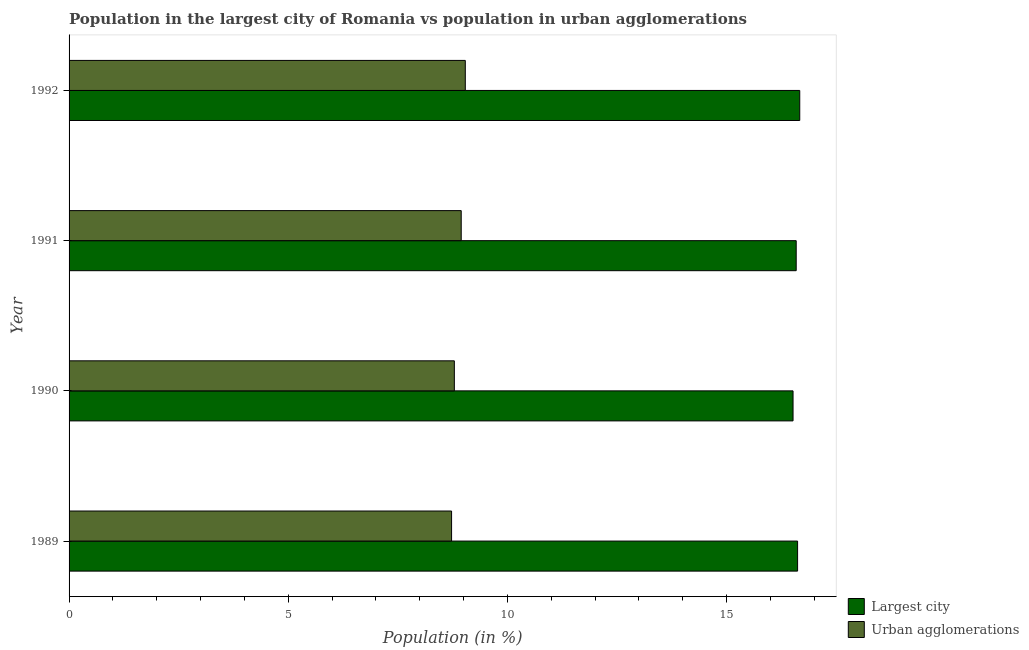Are the number of bars per tick equal to the number of legend labels?
Your answer should be compact. Yes. Are the number of bars on each tick of the Y-axis equal?
Your answer should be very brief. Yes. How many bars are there on the 2nd tick from the bottom?
Offer a very short reply. 2. What is the population in urban agglomerations in 1989?
Offer a terse response. 8.73. Across all years, what is the maximum population in urban agglomerations?
Your response must be concise. 9.04. Across all years, what is the minimum population in urban agglomerations?
Your answer should be very brief. 8.73. In which year was the population in urban agglomerations minimum?
Your response must be concise. 1989. What is the total population in urban agglomerations in the graph?
Offer a very short reply. 35.5. What is the difference between the population in urban agglomerations in 1990 and that in 1992?
Offer a terse response. -0.25. What is the difference between the population in the largest city in 1992 and the population in urban agglomerations in 1989?
Give a very brief answer. 7.94. What is the average population in the largest city per year?
Provide a short and direct response. 16.6. In the year 1992, what is the difference between the population in the largest city and population in urban agglomerations?
Your answer should be compact. 7.63. Is the population in urban agglomerations in 1991 less than that in 1992?
Offer a terse response. Yes. Is the difference between the population in urban agglomerations in 1989 and 1991 greater than the difference between the population in the largest city in 1989 and 1991?
Offer a terse response. No. What is the difference between the highest and the second highest population in the largest city?
Ensure brevity in your answer.  0.05. In how many years, is the population in the largest city greater than the average population in the largest city taken over all years?
Your answer should be very brief. 2. What does the 2nd bar from the top in 1990 represents?
Keep it short and to the point. Largest city. What does the 2nd bar from the bottom in 1992 represents?
Make the answer very short. Urban agglomerations. Are all the bars in the graph horizontal?
Your response must be concise. Yes. What is the difference between two consecutive major ticks on the X-axis?
Give a very brief answer. 5. Does the graph contain grids?
Your response must be concise. No. Where does the legend appear in the graph?
Make the answer very short. Bottom right. How are the legend labels stacked?
Provide a short and direct response. Vertical. What is the title of the graph?
Your answer should be compact. Population in the largest city of Romania vs population in urban agglomerations. Does "Resident" appear as one of the legend labels in the graph?
Offer a terse response. No. What is the label or title of the Y-axis?
Offer a terse response. Year. What is the Population (in %) in Largest city in 1989?
Your answer should be very brief. 16.62. What is the Population (in %) of Urban agglomerations in 1989?
Offer a very short reply. 8.73. What is the Population (in %) in Largest city in 1990?
Offer a terse response. 16.52. What is the Population (in %) in Urban agglomerations in 1990?
Your answer should be very brief. 8.79. What is the Population (in %) of Largest city in 1991?
Provide a short and direct response. 16.59. What is the Population (in %) of Urban agglomerations in 1991?
Offer a very short reply. 8.95. What is the Population (in %) in Largest city in 1992?
Offer a terse response. 16.67. What is the Population (in %) of Urban agglomerations in 1992?
Offer a terse response. 9.04. Across all years, what is the maximum Population (in %) of Largest city?
Give a very brief answer. 16.67. Across all years, what is the maximum Population (in %) in Urban agglomerations?
Offer a very short reply. 9.04. Across all years, what is the minimum Population (in %) in Largest city?
Keep it short and to the point. 16.52. Across all years, what is the minimum Population (in %) of Urban agglomerations?
Provide a short and direct response. 8.73. What is the total Population (in %) of Largest city in the graph?
Offer a very short reply. 66.4. What is the total Population (in %) in Urban agglomerations in the graph?
Your answer should be compact. 35.5. What is the difference between the Population (in %) in Largest city in 1989 and that in 1990?
Ensure brevity in your answer.  0.1. What is the difference between the Population (in %) of Urban agglomerations in 1989 and that in 1990?
Make the answer very short. -0.06. What is the difference between the Population (in %) in Largest city in 1989 and that in 1991?
Keep it short and to the point. 0.03. What is the difference between the Population (in %) in Urban agglomerations in 1989 and that in 1991?
Provide a succinct answer. -0.22. What is the difference between the Population (in %) of Largest city in 1989 and that in 1992?
Ensure brevity in your answer.  -0.05. What is the difference between the Population (in %) in Urban agglomerations in 1989 and that in 1992?
Provide a short and direct response. -0.31. What is the difference between the Population (in %) of Largest city in 1990 and that in 1991?
Give a very brief answer. -0.07. What is the difference between the Population (in %) of Urban agglomerations in 1990 and that in 1991?
Your answer should be compact. -0.16. What is the difference between the Population (in %) of Largest city in 1990 and that in 1992?
Offer a very short reply. -0.15. What is the difference between the Population (in %) of Urban agglomerations in 1990 and that in 1992?
Your answer should be very brief. -0.25. What is the difference between the Population (in %) of Largest city in 1991 and that in 1992?
Your answer should be compact. -0.08. What is the difference between the Population (in %) in Urban agglomerations in 1991 and that in 1992?
Provide a short and direct response. -0.09. What is the difference between the Population (in %) in Largest city in 1989 and the Population (in %) in Urban agglomerations in 1990?
Give a very brief answer. 7.83. What is the difference between the Population (in %) in Largest city in 1989 and the Population (in %) in Urban agglomerations in 1991?
Give a very brief answer. 7.67. What is the difference between the Population (in %) in Largest city in 1989 and the Population (in %) in Urban agglomerations in 1992?
Give a very brief answer. 7.58. What is the difference between the Population (in %) of Largest city in 1990 and the Population (in %) of Urban agglomerations in 1991?
Offer a very short reply. 7.57. What is the difference between the Population (in %) in Largest city in 1990 and the Population (in %) in Urban agglomerations in 1992?
Give a very brief answer. 7.48. What is the difference between the Population (in %) in Largest city in 1991 and the Population (in %) in Urban agglomerations in 1992?
Offer a very short reply. 7.55. What is the average Population (in %) of Largest city per year?
Your response must be concise. 16.6. What is the average Population (in %) in Urban agglomerations per year?
Offer a very short reply. 8.88. In the year 1989, what is the difference between the Population (in %) in Largest city and Population (in %) in Urban agglomerations?
Offer a very short reply. 7.89. In the year 1990, what is the difference between the Population (in %) in Largest city and Population (in %) in Urban agglomerations?
Provide a short and direct response. 7.73. In the year 1991, what is the difference between the Population (in %) of Largest city and Population (in %) of Urban agglomerations?
Ensure brevity in your answer.  7.64. In the year 1992, what is the difference between the Population (in %) in Largest city and Population (in %) in Urban agglomerations?
Make the answer very short. 7.63. What is the ratio of the Population (in %) in Urban agglomerations in 1989 to that in 1991?
Offer a very short reply. 0.98. What is the ratio of the Population (in %) of Urban agglomerations in 1989 to that in 1992?
Offer a terse response. 0.97. What is the ratio of the Population (in %) in Largest city in 1990 to that in 1991?
Your response must be concise. 1. What is the ratio of the Population (in %) in Urban agglomerations in 1990 to that in 1991?
Keep it short and to the point. 0.98. What is the ratio of the Population (in %) of Urban agglomerations in 1990 to that in 1992?
Offer a terse response. 0.97. What is the difference between the highest and the second highest Population (in %) in Largest city?
Keep it short and to the point. 0.05. What is the difference between the highest and the second highest Population (in %) of Urban agglomerations?
Your answer should be compact. 0.09. What is the difference between the highest and the lowest Population (in %) in Largest city?
Your answer should be compact. 0.15. What is the difference between the highest and the lowest Population (in %) of Urban agglomerations?
Your response must be concise. 0.31. 